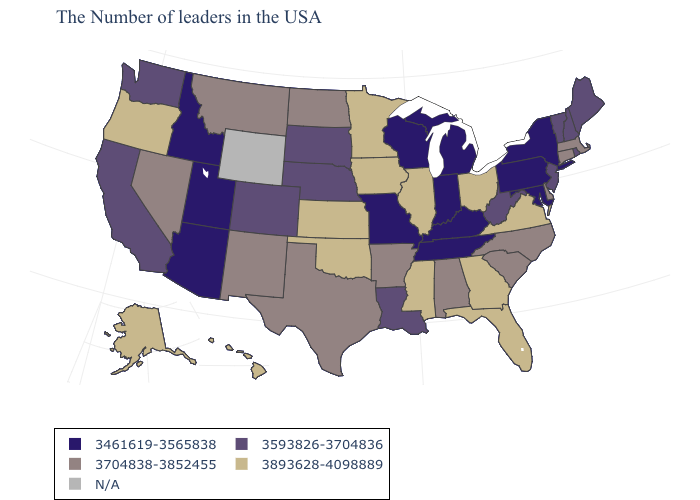Does the first symbol in the legend represent the smallest category?
Quick response, please. Yes. What is the value of South Carolina?
Answer briefly. 3704838-3852455. What is the value of Louisiana?
Give a very brief answer. 3593826-3704836. Does Arkansas have the highest value in the USA?
Short answer required. No. Does Vermont have the highest value in the USA?
Concise answer only. No. Is the legend a continuous bar?
Quick response, please. No. What is the value of Arizona?
Concise answer only. 3461619-3565838. Name the states that have a value in the range 3704838-3852455?
Concise answer only. Massachusetts, Connecticut, Delaware, North Carolina, South Carolina, Alabama, Arkansas, Texas, North Dakota, New Mexico, Montana, Nevada. What is the lowest value in the West?
Give a very brief answer. 3461619-3565838. Does Connecticut have the lowest value in the Northeast?
Be succinct. No. What is the lowest value in the Northeast?
Quick response, please. 3461619-3565838. What is the value of Georgia?
Short answer required. 3893628-4098889. Name the states that have a value in the range 3461619-3565838?
Keep it brief. New York, Maryland, Pennsylvania, Michigan, Kentucky, Indiana, Tennessee, Wisconsin, Missouri, Utah, Arizona, Idaho. How many symbols are there in the legend?
Give a very brief answer. 5. 